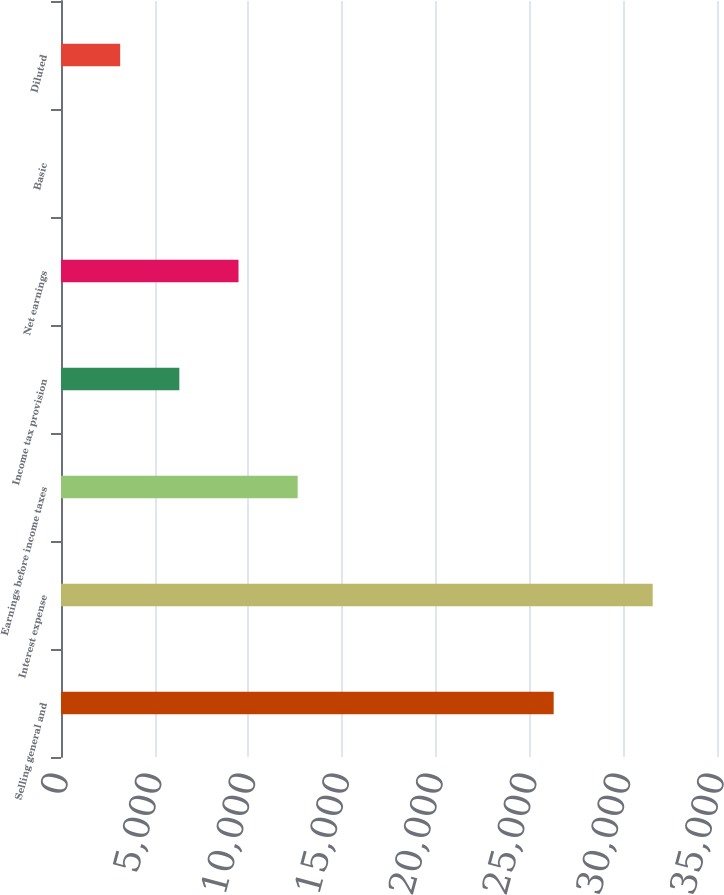<chart> <loc_0><loc_0><loc_500><loc_500><bar_chart><fcel>Selling general and<fcel>Interest expense<fcel>Earnings before income taxes<fcel>Income tax provision<fcel>Net earnings<fcel>Basic<fcel>Diluted<nl><fcel>26286<fcel>31570<fcel>12628<fcel>6314.02<fcel>9471.02<fcel>0.02<fcel>3157.02<nl></chart> 